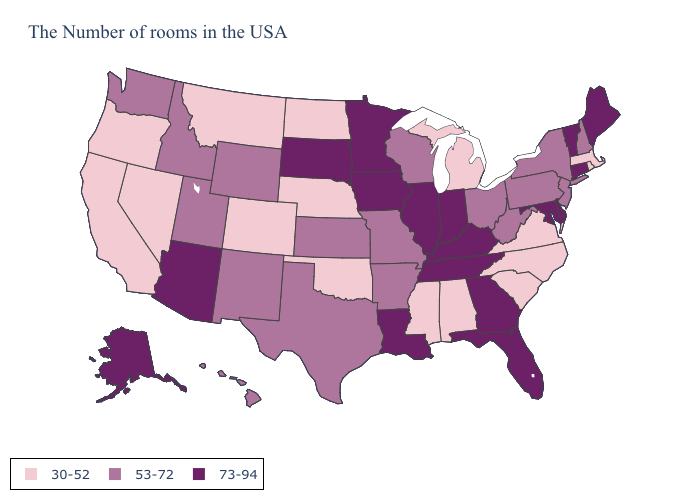Does Wyoming have the lowest value in the USA?
Be succinct. No. Name the states that have a value in the range 30-52?
Be succinct. Massachusetts, Rhode Island, Virginia, North Carolina, South Carolina, Michigan, Alabama, Mississippi, Nebraska, Oklahoma, North Dakota, Colorado, Montana, Nevada, California, Oregon. What is the highest value in the USA?
Be succinct. 73-94. Name the states that have a value in the range 53-72?
Short answer required. New Hampshire, New York, New Jersey, Pennsylvania, West Virginia, Ohio, Wisconsin, Missouri, Arkansas, Kansas, Texas, Wyoming, New Mexico, Utah, Idaho, Washington, Hawaii. Name the states that have a value in the range 53-72?
Quick response, please. New Hampshire, New York, New Jersey, Pennsylvania, West Virginia, Ohio, Wisconsin, Missouri, Arkansas, Kansas, Texas, Wyoming, New Mexico, Utah, Idaho, Washington, Hawaii. Which states hav the highest value in the Northeast?
Write a very short answer. Maine, Vermont, Connecticut. What is the lowest value in the Northeast?
Concise answer only. 30-52. What is the value of Louisiana?
Short answer required. 73-94. Which states hav the highest value in the MidWest?
Short answer required. Indiana, Illinois, Minnesota, Iowa, South Dakota. Name the states that have a value in the range 53-72?
Answer briefly. New Hampshire, New York, New Jersey, Pennsylvania, West Virginia, Ohio, Wisconsin, Missouri, Arkansas, Kansas, Texas, Wyoming, New Mexico, Utah, Idaho, Washington, Hawaii. What is the value of Minnesota?
Short answer required. 73-94. Does Idaho have the same value as Utah?
Answer briefly. Yes. What is the value of South Carolina?
Answer briefly. 30-52. What is the value of Virginia?
Answer briefly. 30-52. What is the highest value in the USA?
Short answer required. 73-94. 